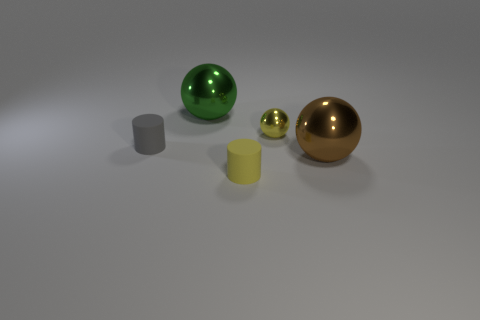Subtract all large shiny balls. How many balls are left? 1 Add 2 large objects. How many objects exist? 7 Subtract 1 balls. How many balls are left? 2 Subtract all balls. How many objects are left? 2 Subtract all tiny gray rubber cylinders. Subtract all small gray metal blocks. How many objects are left? 4 Add 5 green objects. How many green objects are left? 6 Add 5 small yellow cylinders. How many small yellow cylinders exist? 6 Subtract 0 cyan cubes. How many objects are left? 5 